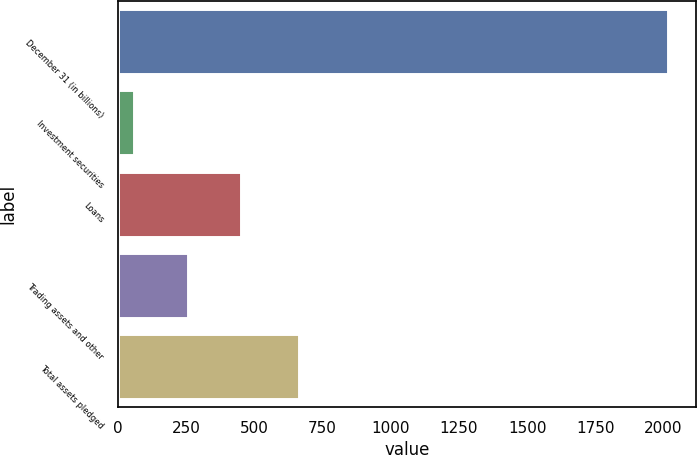Convert chart. <chart><loc_0><loc_0><loc_500><loc_500><bar_chart><fcel>December 31 (in billions)<fcel>Investment securities<fcel>Loans<fcel>Trading assets and other<fcel>Total assets pledged<nl><fcel>2018<fcel>59.5<fcel>451.2<fcel>255.35<fcel>663<nl></chart> 